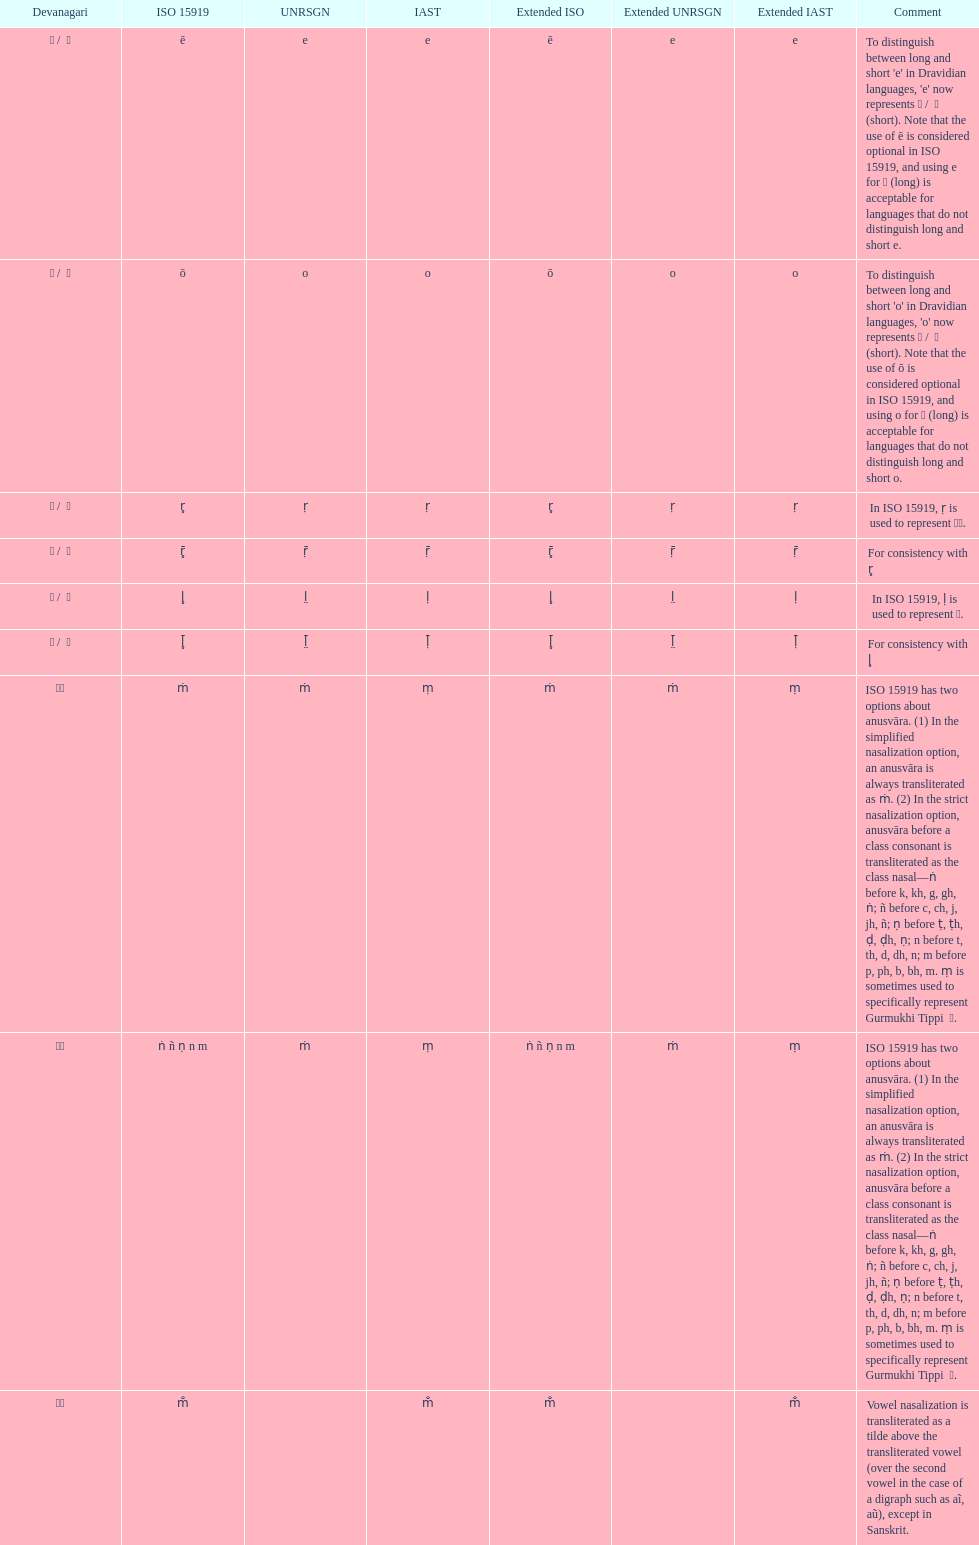What iast is listed before the o? E. 